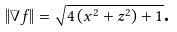<formula> <loc_0><loc_0><loc_500><loc_500>\left \| \nabla f \right \| = \sqrt { 4 \left ( x ^ { 2 } + z ^ { 2 } \right ) + 1 } \text {.}</formula> 